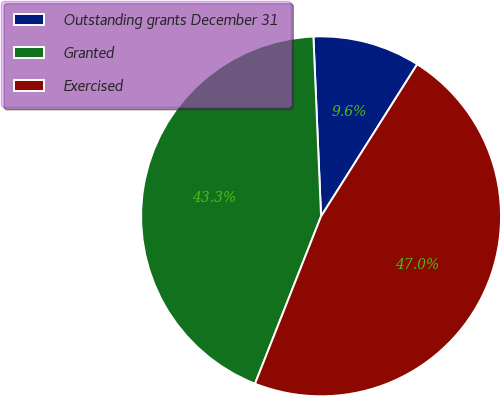Convert chart to OTSL. <chart><loc_0><loc_0><loc_500><loc_500><pie_chart><fcel>Outstanding grants December 31<fcel>Granted<fcel>Exercised<nl><fcel>9.65%<fcel>43.34%<fcel>47.01%<nl></chart> 